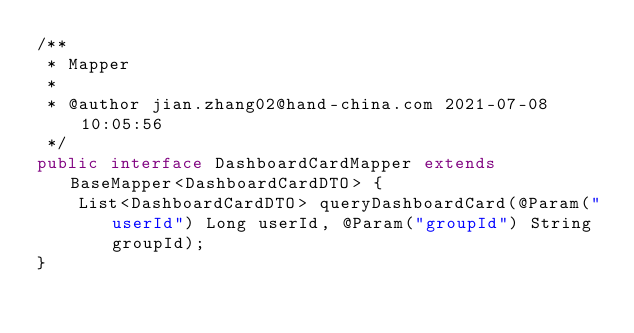<code> <loc_0><loc_0><loc_500><loc_500><_Java_>/**
 * Mapper
 *
 * @author jian.zhang02@hand-china.com 2021-07-08 10:05:56
 */
public interface DashboardCardMapper extends BaseMapper<DashboardCardDTO> {
    List<DashboardCardDTO> queryDashboardCard(@Param("userId") Long userId, @Param("groupId") String groupId);
}
</code> 